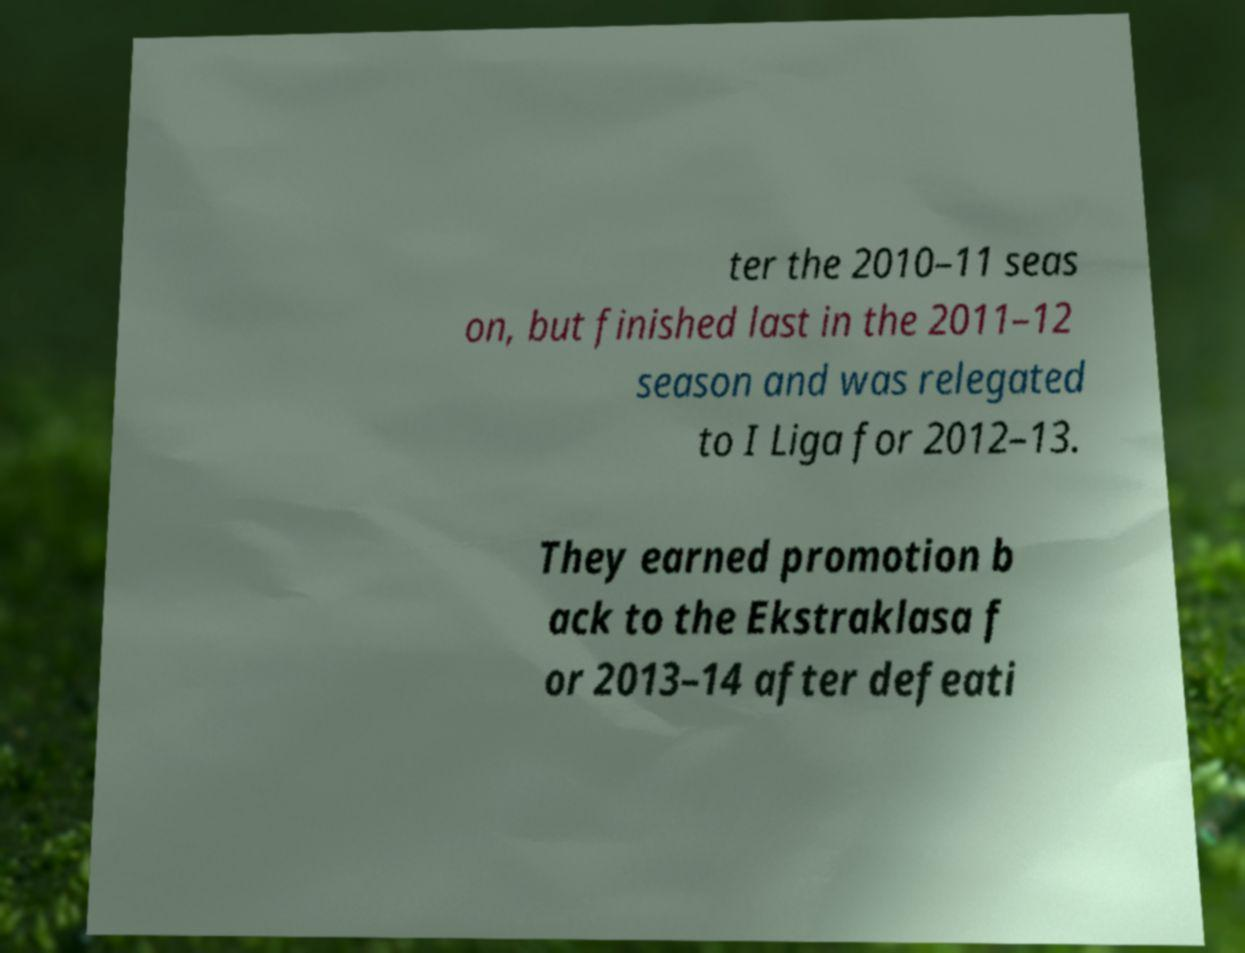Could you assist in decoding the text presented in this image and type it out clearly? ter the 2010–11 seas on, but finished last in the 2011–12 season and was relegated to I Liga for 2012–13. They earned promotion b ack to the Ekstraklasa f or 2013–14 after defeati 